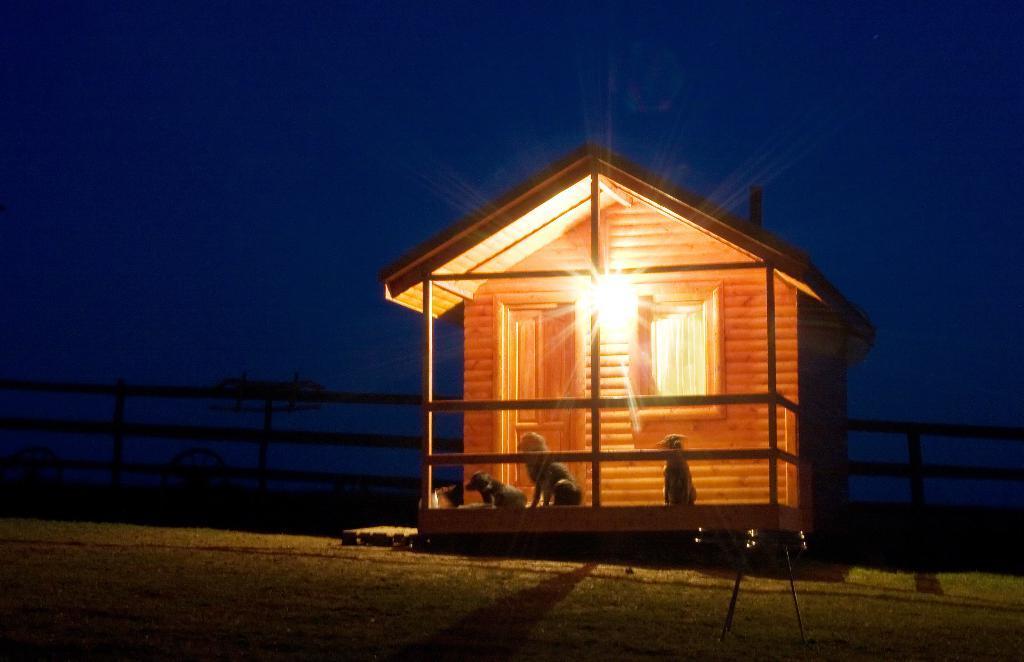Describe this image in one or two sentences. In the picture I can see a wooden house and there is a light attached to it and there are three dogs in front of it and there is a fence in the background. 